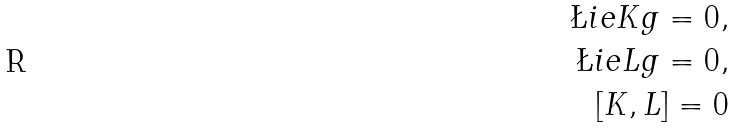<formula> <loc_0><loc_0><loc_500><loc_500>\L i e { K } g = 0 , \\ \L i e { L } g = 0 , \\ [ K , L ] = 0</formula> 